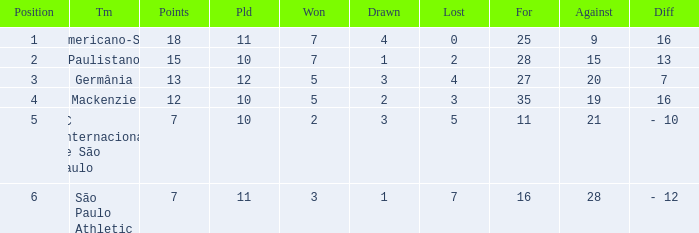Name the least for when played is 12 27.0. 